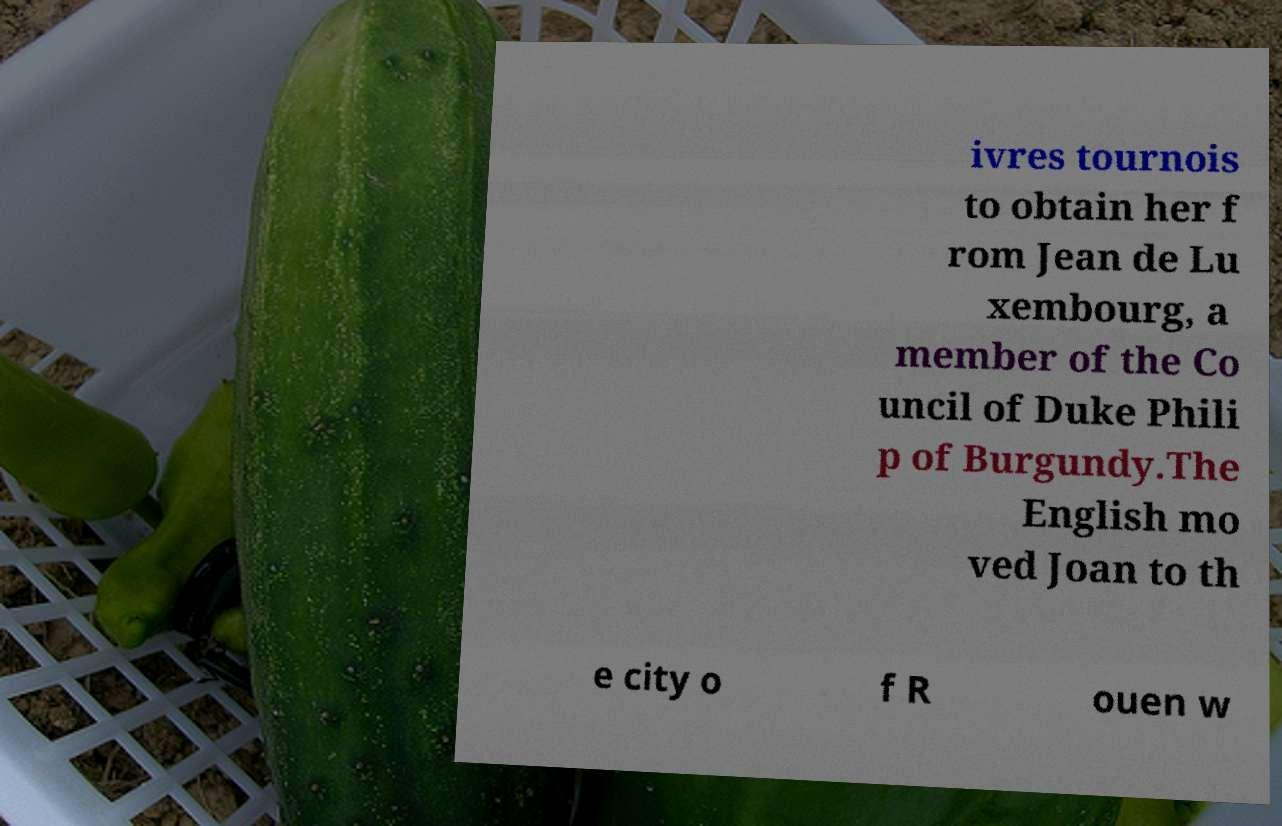Please read and relay the text visible in this image. What does it say? ivres tournois to obtain her f rom Jean de Lu xembourg, a member of the Co uncil of Duke Phili p of Burgundy.The English mo ved Joan to th e city o f R ouen w 